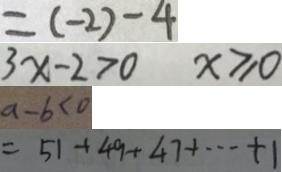<formula> <loc_0><loc_0><loc_500><loc_500>= ( - 2 ) - 4 
 3 x - 2 > 0 x \geqslant 0 
 a - b < 0 
 = 5 1 + 4 9 + 4 7 + \cdots + 1</formula> 